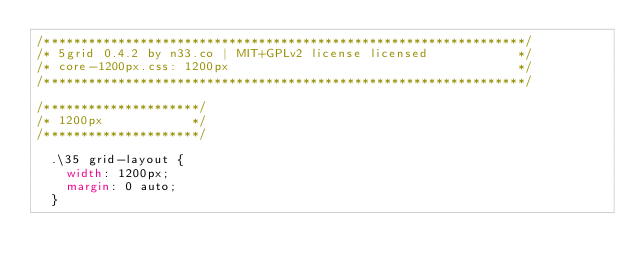Convert code to text. <code><loc_0><loc_0><loc_500><loc_500><_CSS_>/*****************************************************************/
/* 5grid 0.4.2 by n33.co | MIT+GPLv2 license licensed            */
/* core-1200px.css: 1200px                                       */
/*****************************************************************/

/*********************/
/* 1200px            */
/*********************/

	.\35 grid-layout {
		width: 1200px;
		margin: 0 auto;
	}</code> 